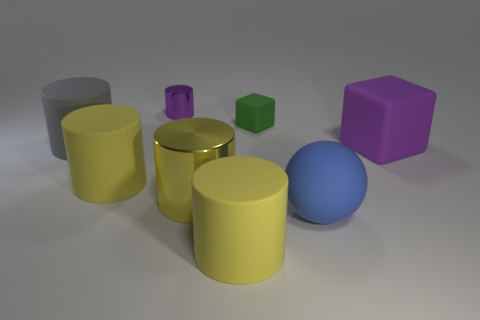Subtract all purple cubes. How many yellow cylinders are left? 3 Subtract all tiny purple cylinders. How many cylinders are left? 4 Subtract all gray cylinders. How many cylinders are left? 4 Add 1 green objects. How many objects exist? 9 Subtract all green cylinders. Subtract all blue blocks. How many cylinders are left? 5 Subtract all spheres. How many objects are left? 7 Subtract all big blue rubber things. Subtract all large purple matte things. How many objects are left? 6 Add 2 rubber objects. How many rubber objects are left? 8 Add 4 big gray balls. How many big gray balls exist? 4 Subtract 0 blue cylinders. How many objects are left? 8 